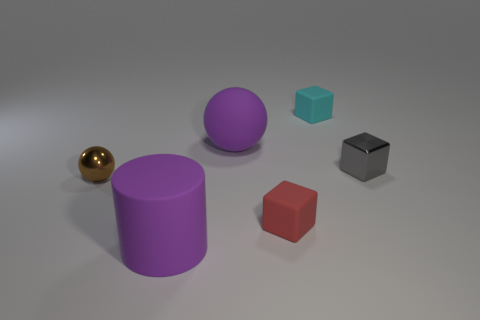If this were a photograph, what kind of environment would suggest such an arrangement of objects? If this were a photograph, the arrangement of objects could suggest a controlled, studio-like environment, commonly used for product photography or a visual study of shapes and colors. The neutral background and intentional placement hint at a desire to draw attention to the objects' characteristics without external distractions. 